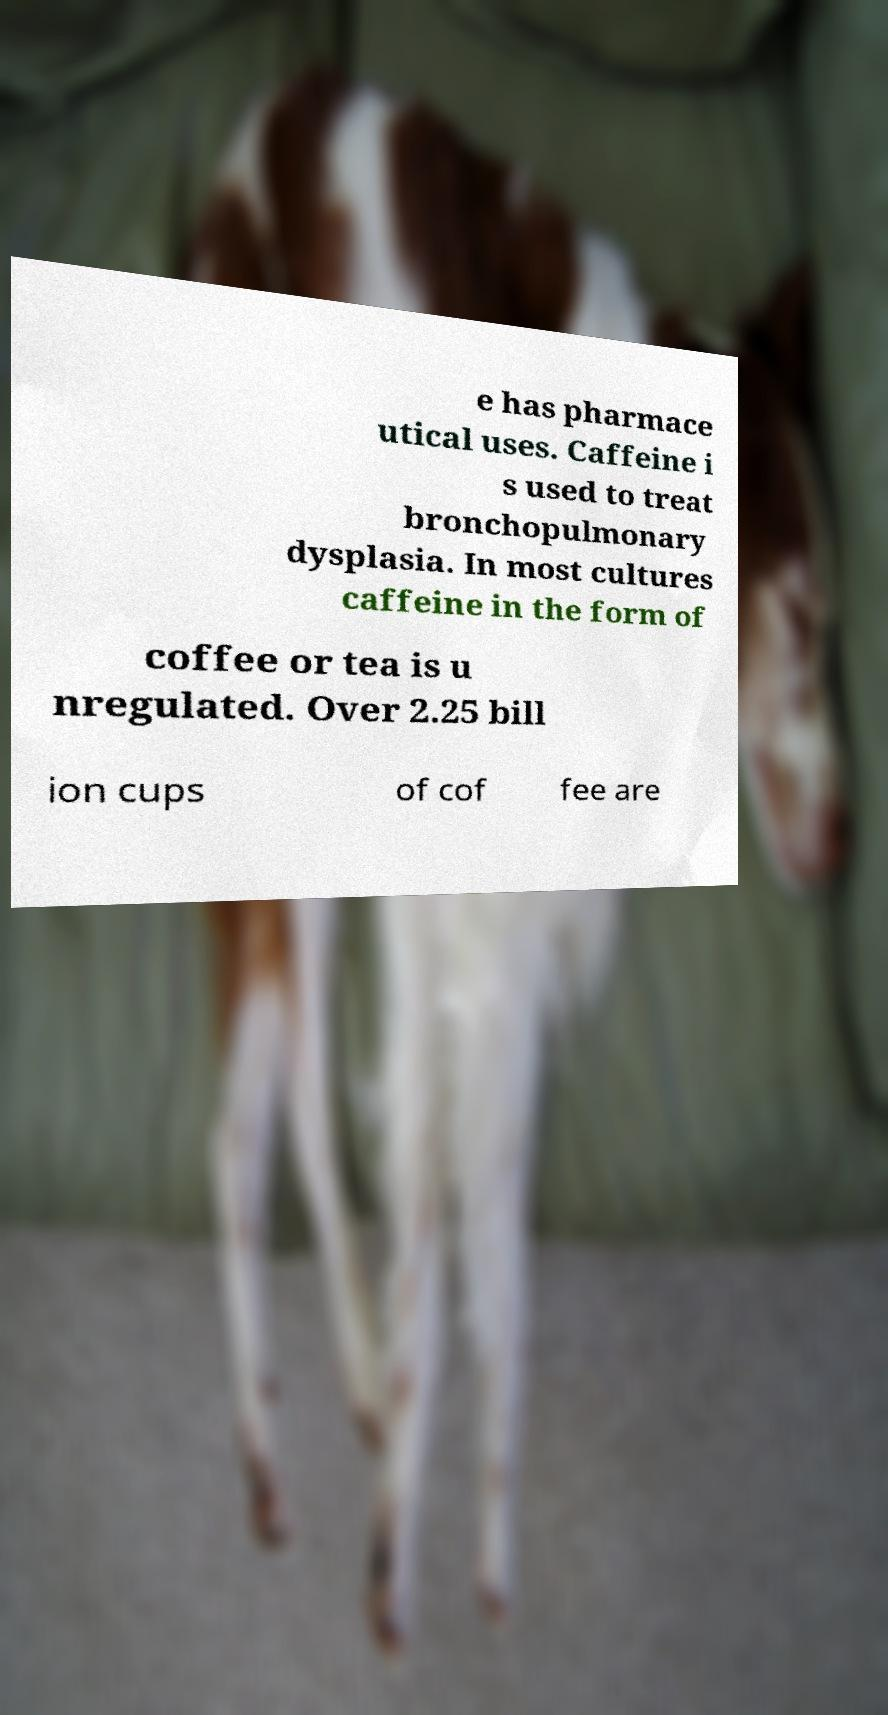What messages or text are displayed in this image? I need them in a readable, typed format. e has pharmace utical uses. Caffeine i s used to treat bronchopulmonary dysplasia. In most cultures caffeine in the form of coffee or tea is u nregulated. Over 2.25 bill ion cups of cof fee are 